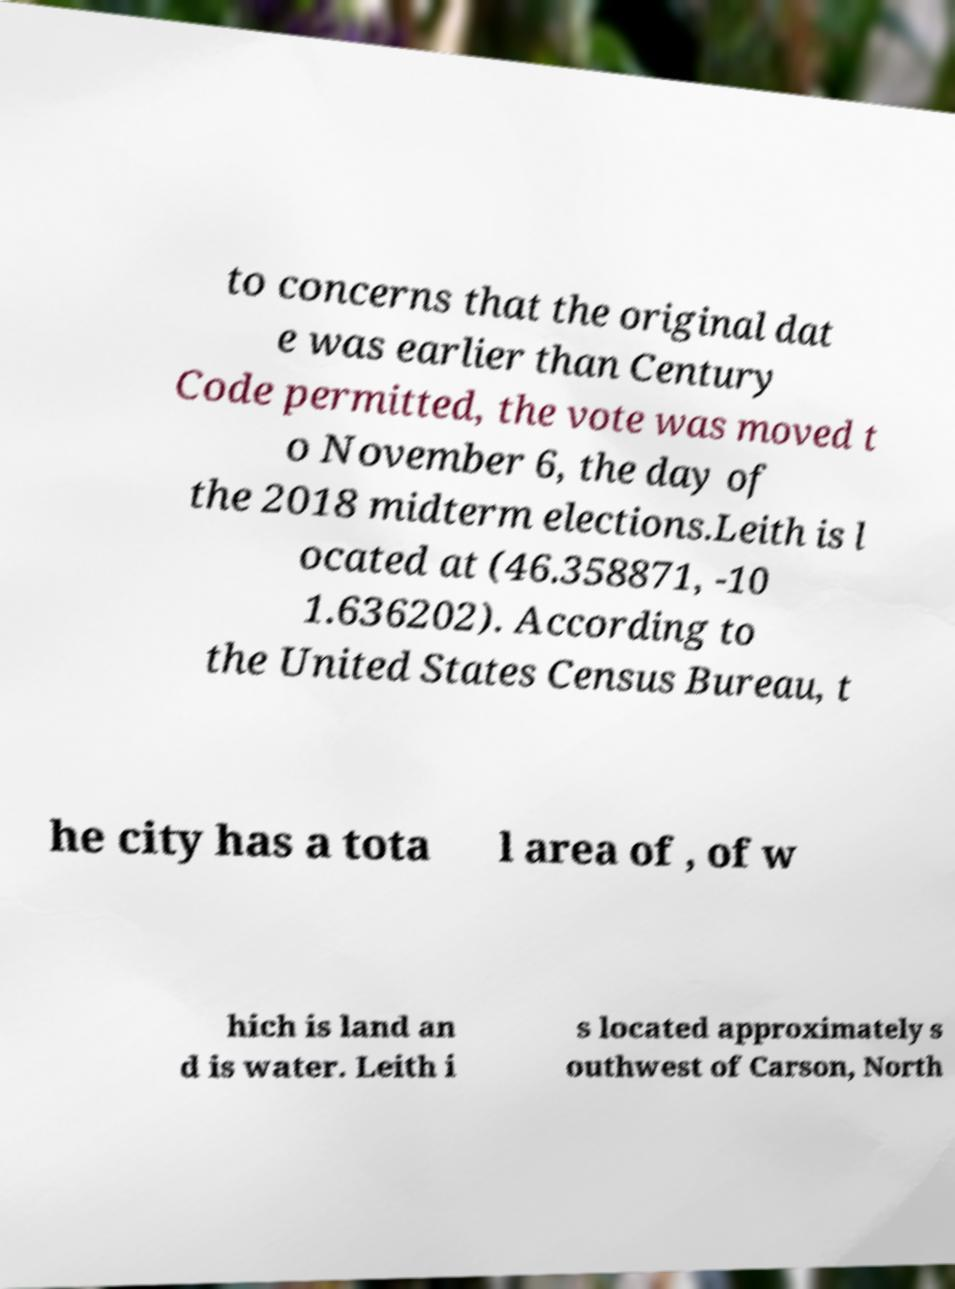Please read and relay the text visible in this image. What does it say? to concerns that the original dat e was earlier than Century Code permitted, the vote was moved t o November 6, the day of the 2018 midterm elections.Leith is l ocated at (46.358871, -10 1.636202). According to the United States Census Bureau, t he city has a tota l area of , of w hich is land an d is water. Leith i s located approximately s outhwest of Carson, North 